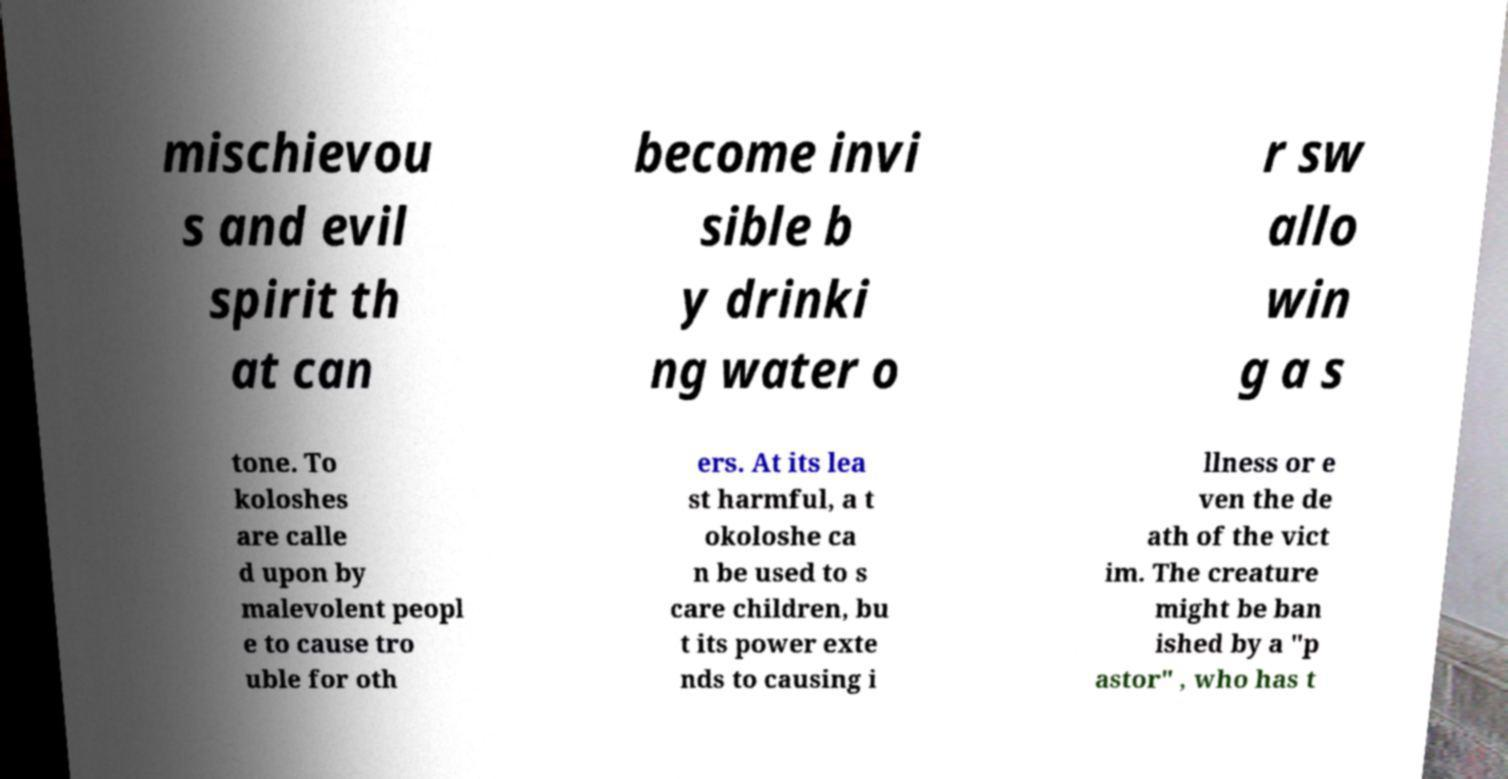Please identify and transcribe the text found in this image. mischievou s and evil spirit th at can become invi sible b y drinki ng water o r sw allo win g a s tone. To koloshes are calle d upon by malevolent peopl e to cause tro uble for oth ers. At its lea st harmful, a t okoloshe ca n be used to s care children, bu t its power exte nds to causing i llness or e ven the de ath of the vict im. The creature might be ban ished by a "p astor" , who has t 